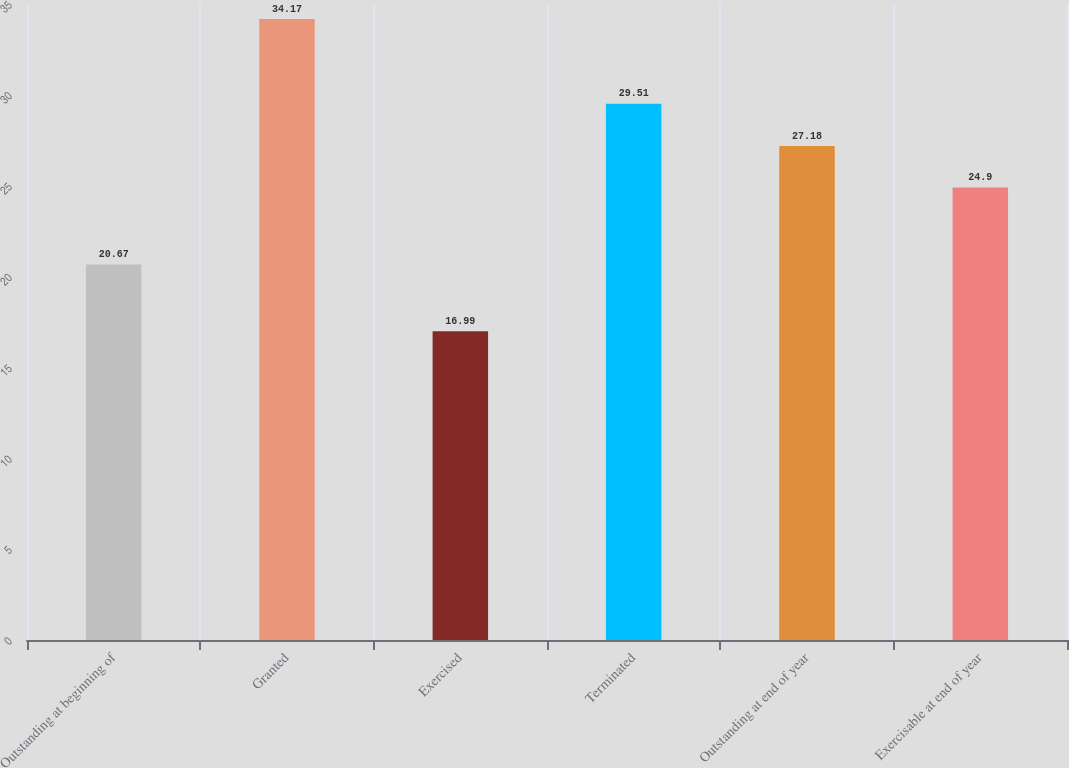Convert chart. <chart><loc_0><loc_0><loc_500><loc_500><bar_chart><fcel>Outstanding at beginning of<fcel>Granted<fcel>Exercised<fcel>Terminated<fcel>Outstanding at end of year<fcel>Exercisable at end of year<nl><fcel>20.67<fcel>34.17<fcel>16.99<fcel>29.51<fcel>27.18<fcel>24.9<nl></chart> 